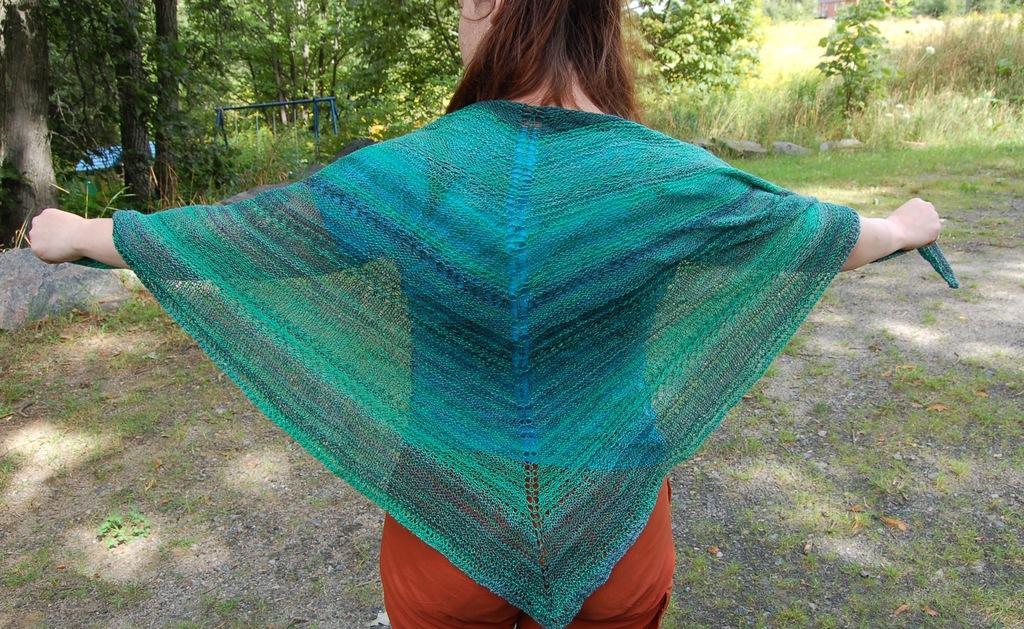Please provide a concise description of this image. In this image I can see a woman wearing orange colored dress is standing and I can see a blue and green colored cloth on her. In the background I can see the ground, few rocks, some grass and few plants which are green in color. 